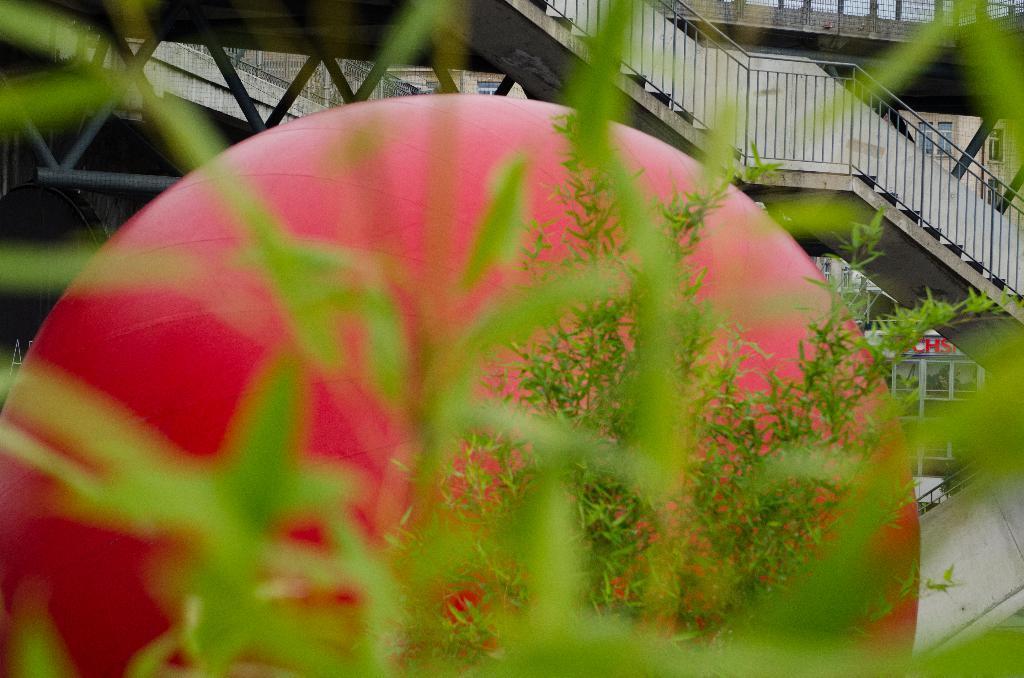Describe this image in one or two sentences. In this picture there is a big red balloon near to the plant. On the right we can see stairs and fencing. In the top right corner there is a bridge. In the background we can see the buildings. At the bottom we can see the grass. 